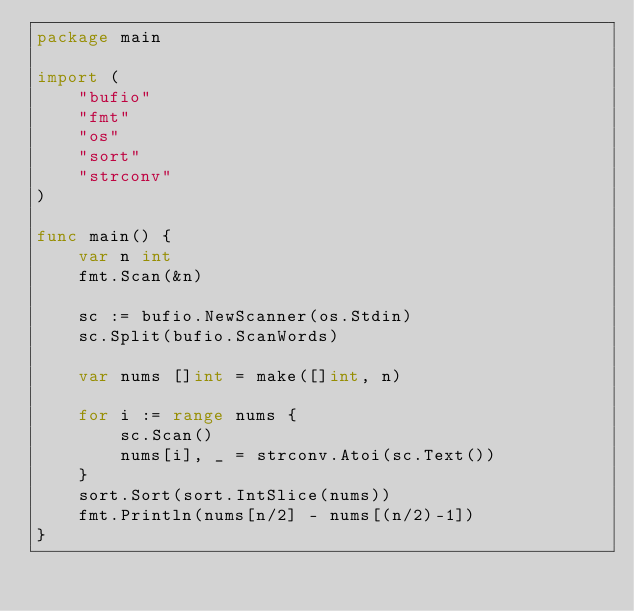<code> <loc_0><loc_0><loc_500><loc_500><_Go_>package main

import (
	"bufio"
	"fmt"
	"os"
	"sort"
	"strconv"
)

func main() {
	var n int
	fmt.Scan(&n)

	sc := bufio.NewScanner(os.Stdin)
	sc.Split(bufio.ScanWords)

	var nums []int = make([]int, n)

	for i := range nums {
		sc.Scan()
		nums[i], _ = strconv.Atoi(sc.Text())
	}
	sort.Sort(sort.IntSlice(nums))
	fmt.Println(nums[n/2] - nums[(n/2)-1])
}
</code> 